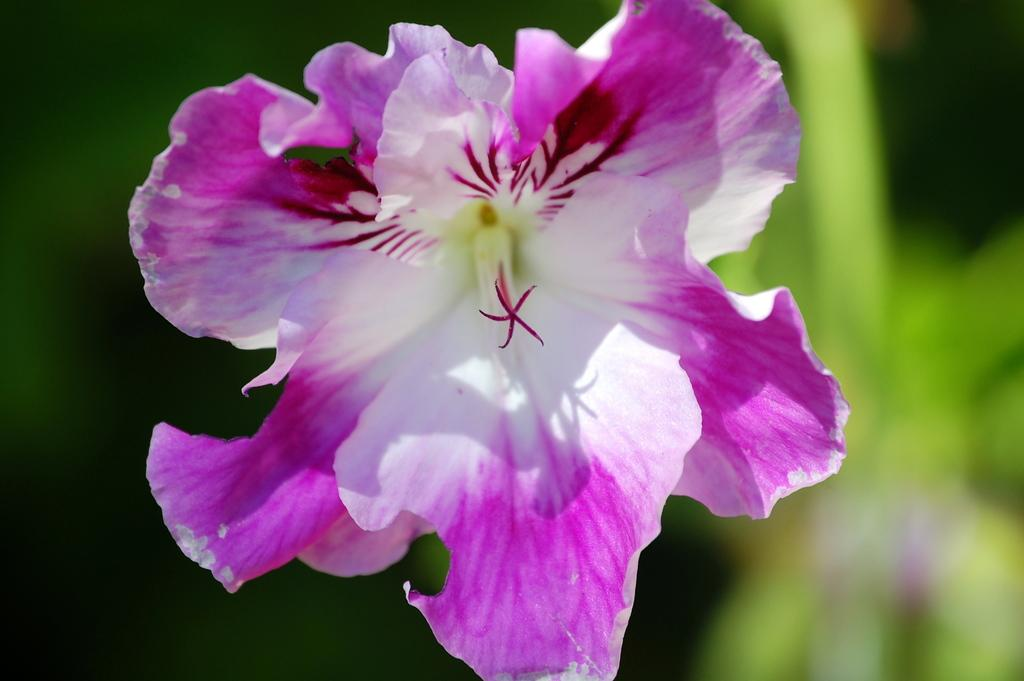What is the main subject of the image? There is a flower in the image. Can you describe the background of the image? The background behind the flower is blurred. How much money is being exchanged in the image? There is no money or exchange of money depicted in the image; it features a flower with a blurred background. What type of kettle is visible in the image? There is no kettle present in the image. 